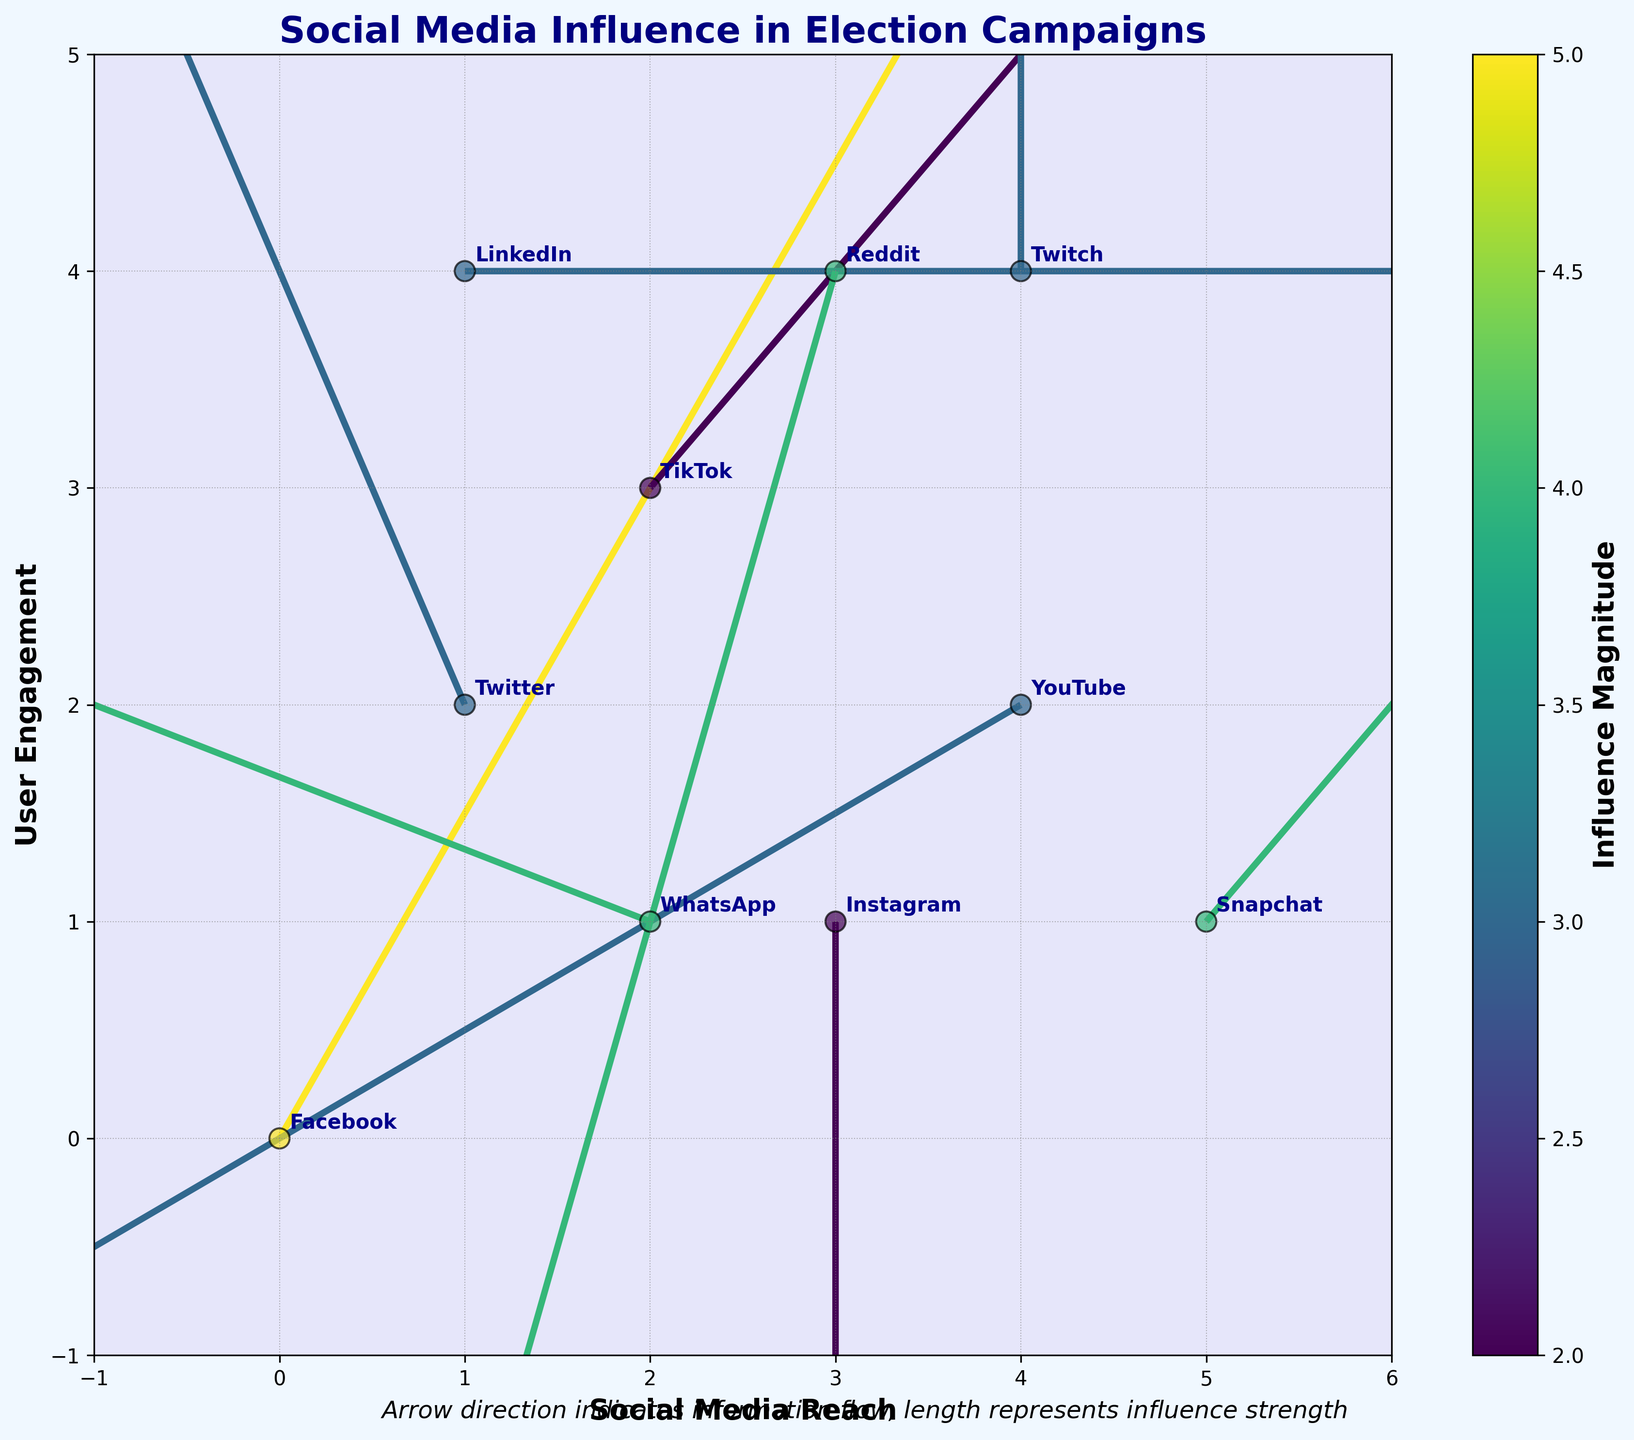what does the title of the figure indicate? The title "Social Media Influence in Election Campaigns" indicates that the plot shows how different social media platforms influence election campaigns. Each arrow suggests an influence direction and magnitude.
Answer: Social Media Influence in Election Campaigns How many total social media platforms are depicted in the figure? By counting the labeled points in the plot, we can see there are 10 social media platforms: Facebook, Twitter, Instagram, TikTok, YouTube, LinkedIn, Reddit, Snapchat, WhatsApp, and Twitch.
Answer: 10 Which social media platform has the highest influence magnitude? By looking at the color intensity and the values in the 'magnitude' colorbar, we observe that Snapchat and Reddit arrows are the darkest, indicating the highest influence magnitudes of 4.
Answer: Snapchat and Reddit What is the range of the user engagement axis? The user engagement axis is labeled from -1 to 5 on the plot as indicated by the vertical y-axis.
Answer: -1 to 5 Which platform has the strongest flow towards the negative y direction? By examining the vector arrows pointing downwards, the platform with the largest arrow going downward is Instagram, which has an influence vector (0, -2).
Answer: Instagram What is the overall trend of social media platforms in terms of user engagement and reach? By analyzing the scatter locations and direction of vectors, most arrows do not drastically move away from the central (0,0), suggesting that platforms tend to have diverse but generally moderate influence on both user engagement and reach, with some exceptions.
Answer: Moderate influence with some exceptions Compare the influence magnitude between Twitter and YouTube. Which has a higher influence, and by how much? The magnitude of influence for Twitter is 3 and for YouTube is also 3. Comparing these values, they are the same.
Answer: Equal What is the direction of information flow for LinkedIn? The direction of the arrow for LinkedIn is positive along the x-axis (3,0), meaning the information flow is purely horizontal towards the right.
Answer: Horizontal towards the right Are there any platforms with zero flow in one of the directions? By looking at the arrows, both Instagram and Twitch have zero influence in the x-direction as their horizontal components are 0.
Answer: Instagram and Twitch 